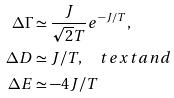Convert formula to latex. <formula><loc_0><loc_0><loc_500><loc_500>\Delta \Gamma & \simeq \frac { J } { \sqrt { 2 } T } e ^ { - J / T } , \\ \Delta D & \simeq J / T , \quad t e x t { a n d } \\ \Delta E & \simeq - 4 J / T</formula> 